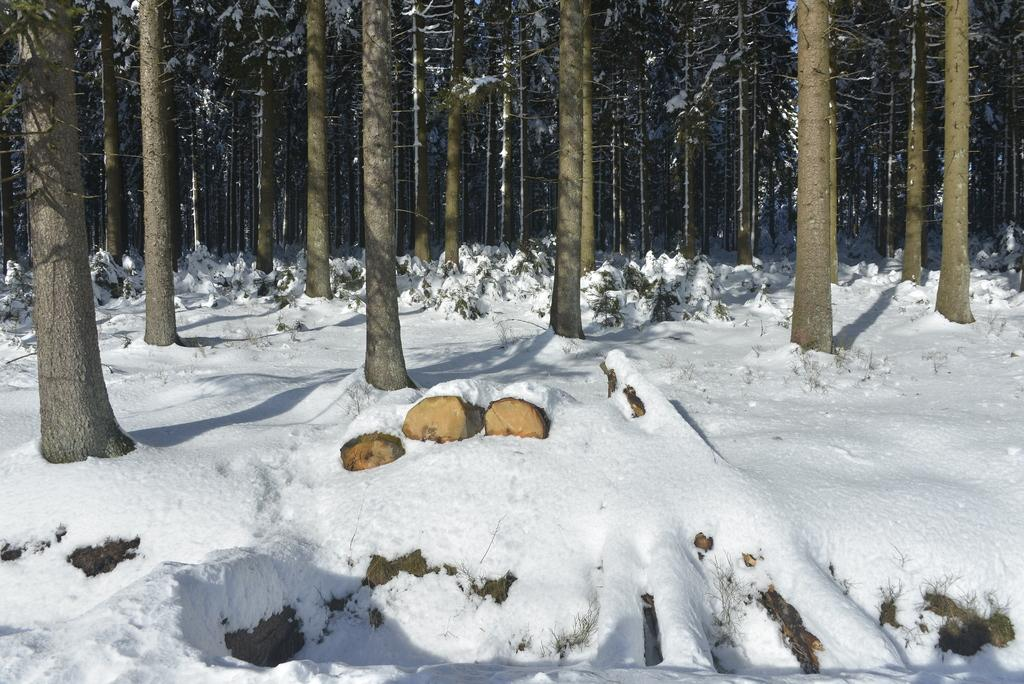What type of vegetation can be seen in the image? There are trees and plants in the image. What material are the logs made of in the image? The logs in the image are made of wood. How is the vegetation and wooden logs depicted in the image? The trees, plants, and wooden logs are covered with snow in the image. What topic are the friends discussing in the image? There are no friends present in the image, so it is not possible to determine what they might be discussing. 